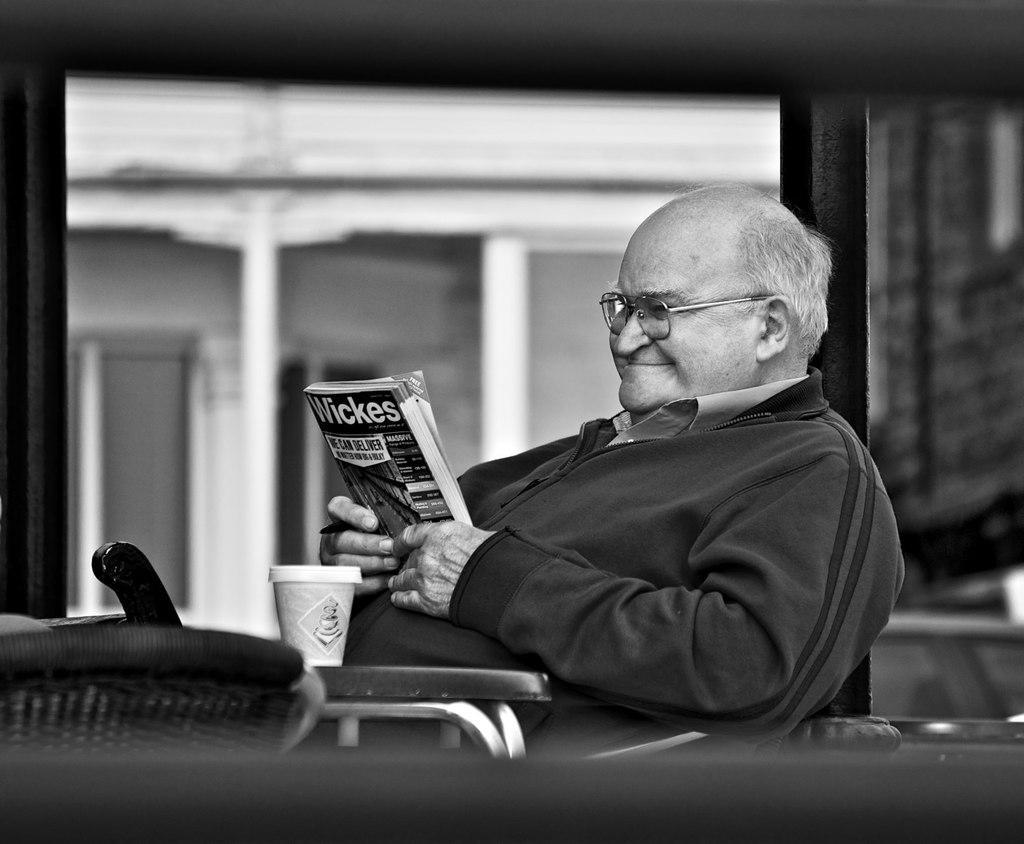In one or two sentences, can you explain what this image depicts? In the middle of the image we can see a man, he is sitting and he is holding a book, in front of him we can see a cup and it is a black and white photography. 